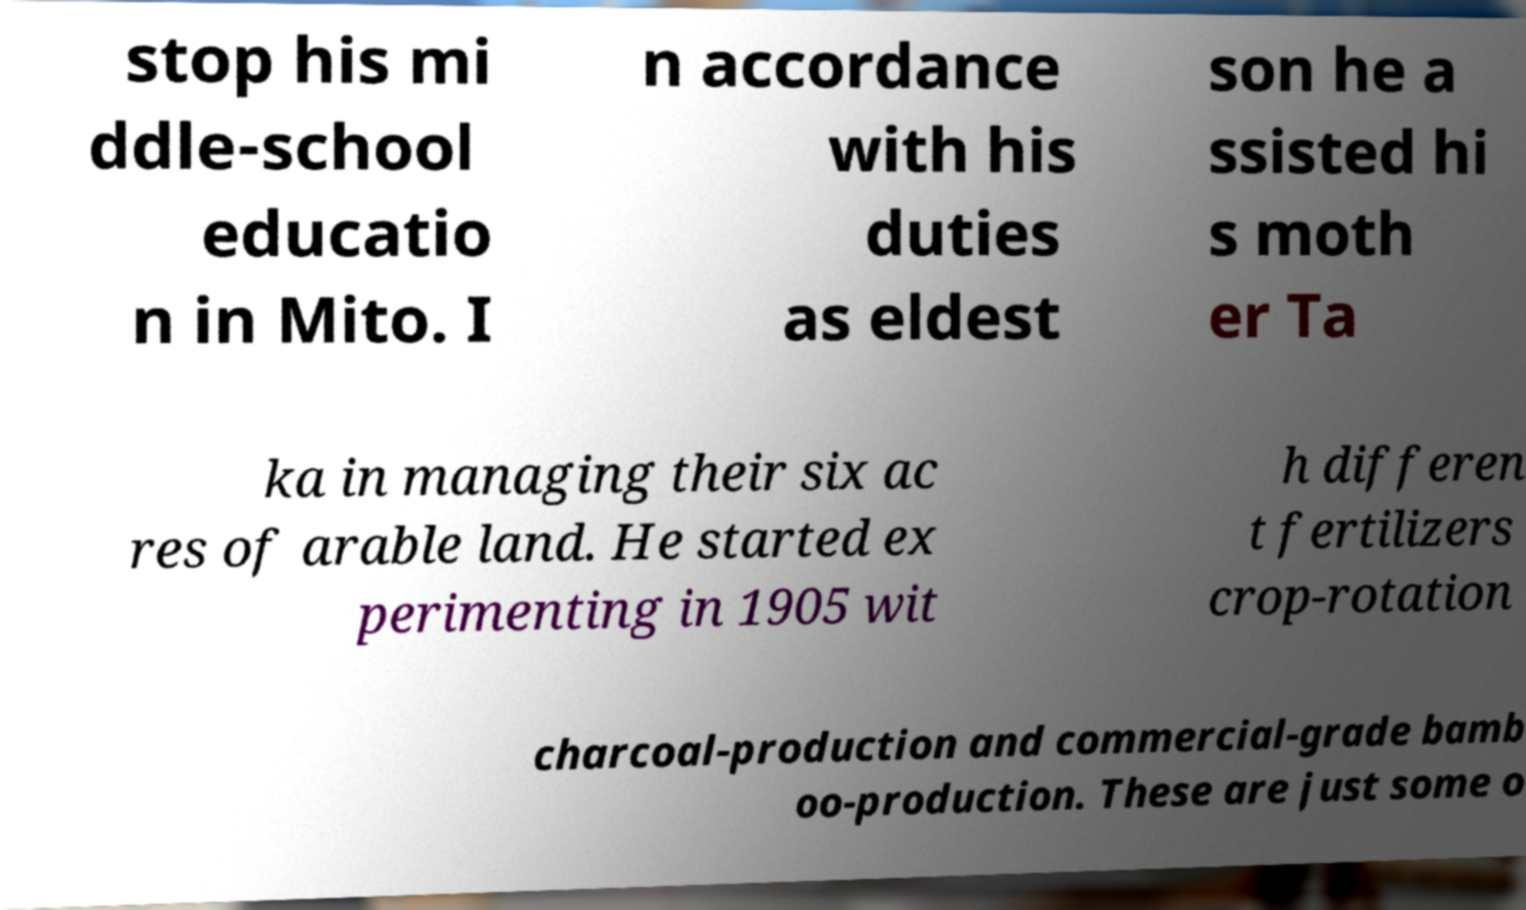Could you extract and type out the text from this image? stop his mi ddle-school educatio n in Mito. I n accordance with his duties as eldest son he a ssisted hi s moth er Ta ka in managing their six ac res of arable land. He started ex perimenting in 1905 wit h differen t fertilizers crop-rotation charcoal-production and commercial-grade bamb oo-production. These are just some o 